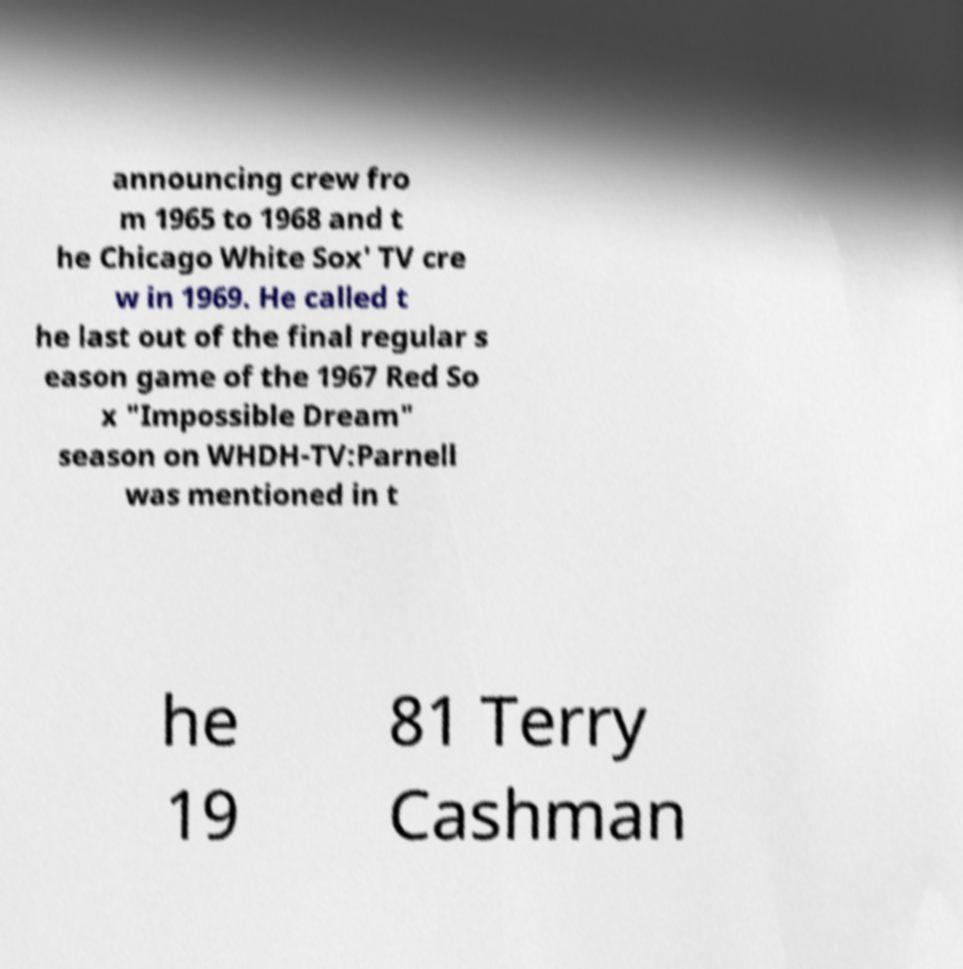Please identify and transcribe the text found in this image. announcing crew fro m 1965 to 1968 and t he Chicago White Sox' TV cre w in 1969. He called t he last out of the final regular s eason game of the 1967 Red So x "Impossible Dream" season on WHDH-TV:Parnell was mentioned in t he 19 81 Terry Cashman 